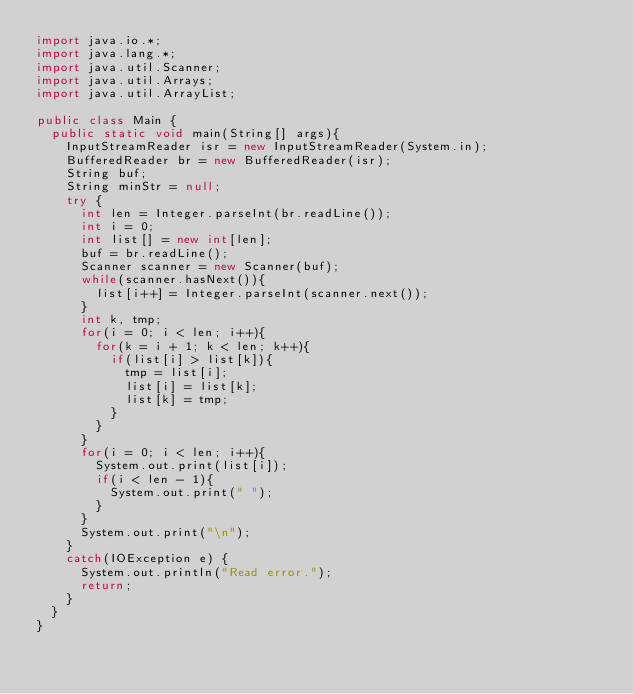<code> <loc_0><loc_0><loc_500><loc_500><_Java_>import java.io.*;
import java.lang.*;
import java.util.Scanner;
import java.util.Arrays;
import java.util.ArrayList;

public class Main {
	public static void main(String[] args){
		InputStreamReader isr = new InputStreamReader(System.in);
		BufferedReader br = new BufferedReader(isr);
		String buf;
		String minStr = null;
		try {
			int len = Integer.parseInt(br.readLine());
			int i = 0;
			int list[] = new int[len];
			buf = br.readLine();
			Scanner scanner = new Scanner(buf);
			while(scanner.hasNext()){
				list[i++] = Integer.parseInt(scanner.next());
			}
			int k, tmp;
			for(i = 0; i < len; i++){
				for(k = i + 1; k < len; k++){
					if(list[i] > list[k]){
						tmp = list[i];
						list[i] = list[k];
						list[k] = tmp;
					}
				}
			}
			for(i = 0; i < len; i++){
				System.out.print(list[i]);
				if(i < len - 1){
					System.out.print(" ");
				}
			}
			System.out.print("\n");
		}
		catch(IOException e) {
			System.out.println("Read error.");
			return;
		}
	}
}</code> 